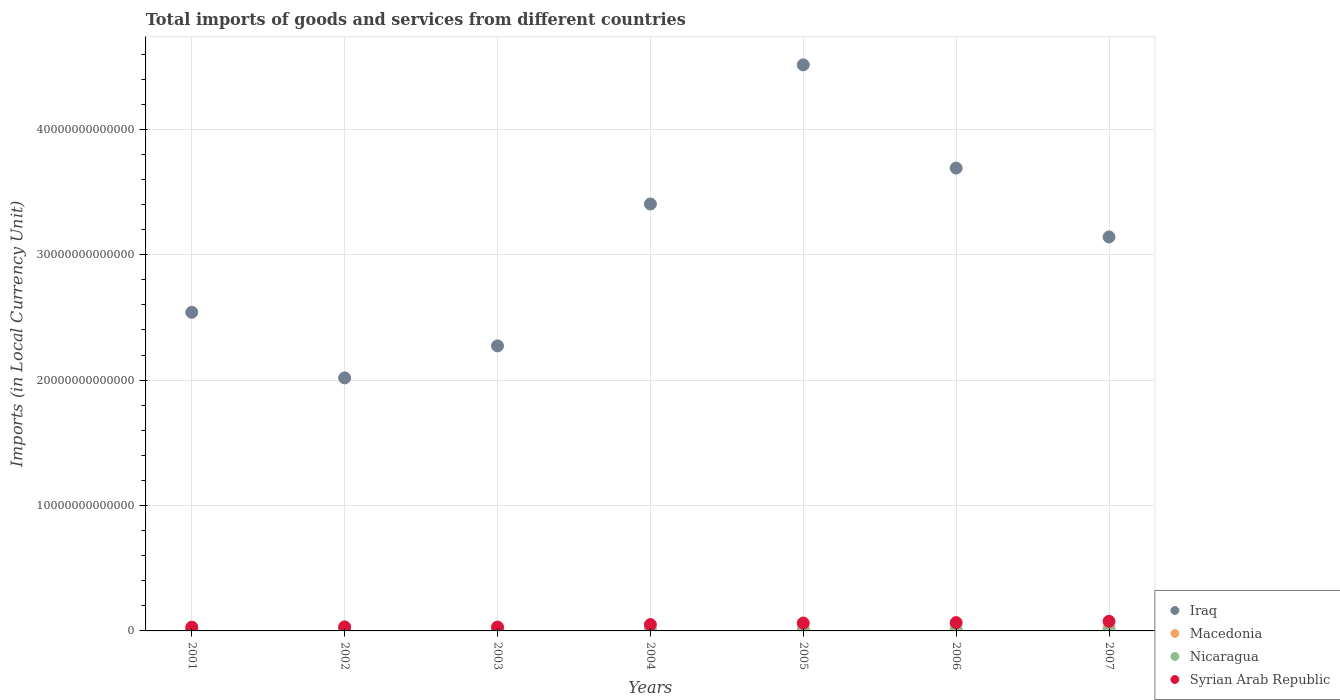What is the Amount of goods and services imports in Nicaragua in 2002?
Your answer should be compact. 2.92e+1. Across all years, what is the maximum Amount of goods and services imports in Iraq?
Your answer should be very brief. 4.51e+13. Across all years, what is the minimum Amount of goods and services imports in Macedonia?
Keep it short and to the point. 1.07e+11. In which year was the Amount of goods and services imports in Syrian Arab Republic maximum?
Provide a short and direct response. 2007. What is the total Amount of goods and services imports in Iraq in the graph?
Give a very brief answer. 2.16e+14. What is the difference between the Amount of goods and services imports in Iraq in 2003 and that in 2004?
Your response must be concise. -1.13e+13. What is the difference between the Amount of goods and services imports in Iraq in 2006 and the Amount of goods and services imports in Nicaragua in 2007?
Keep it short and to the point. 3.68e+13. What is the average Amount of goods and services imports in Nicaragua per year?
Offer a terse response. 4.49e+1. In the year 2005, what is the difference between the Amount of goods and services imports in Syrian Arab Republic and Amount of goods and services imports in Nicaragua?
Offer a terse response. 5.77e+11. What is the ratio of the Amount of goods and services imports in Nicaragua in 2001 to that in 2007?
Offer a terse response. 0.38. Is the difference between the Amount of goods and services imports in Syrian Arab Republic in 2001 and 2007 greater than the difference between the Amount of goods and services imports in Nicaragua in 2001 and 2007?
Provide a succinct answer. No. What is the difference between the highest and the second highest Amount of goods and services imports in Syrian Arab Republic?
Keep it short and to the point. 1.03e+11. What is the difference between the highest and the lowest Amount of goods and services imports in Syrian Arab Republic?
Give a very brief answer. 4.67e+11. In how many years, is the Amount of goods and services imports in Macedonia greater than the average Amount of goods and services imports in Macedonia taken over all years?
Offer a terse response. 3. Is the sum of the Amount of goods and services imports in Syrian Arab Republic in 2003 and 2005 greater than the maximum Amount of goods and services imports in Nicaragua across all years?
Give a very brief answer. Yes. Is it the case that in every year, the sum of the Amount of goods and services imports in Macedonia and Amount of goods and services imports in Nicaragua  is greater than the sum of Amount of goods and services imports in Iraq and Amount of goods and services imports in Syrian Arab Republic?
Your answer should be very brief. Yes. Is it the case that in every year, the sum of the Amount of goods and services imports in Macedonia and Amount of goods and services imports in Syrian Arab Republic  is greater than the Amount of goods and services imports in Iraq?
Make the answer very short. No. How many dotlines are there?
Offer a terse response. 4. What is the difference between two consecutive major ticks on the Y-axis?
Your response must be concise. 1.00e+13. Are the values on the major ticks of Y-axis written in scientific E-notation?
Give a very brief answer. No. Does the graph contain any zero values?
Ensure brevity in your answer.  No. Does the graph contain grids?
Your answer should be compact. Yes. Where does the legend appear in the graph?
Provide a succinct answer. Bottom right. What is the title of the graph?
Provide a succinct answer. Total imports of goods and services from different countries. What is the label or title of the X-axis?
Offer a terse response. Years. What is the label or title of the Y-axis?
Offer a terse response. Imports (in Local Currency Unit). What is the Imports (in Local Currency Unit) of Iraq in 2001?
Your answer should be compact. 2.54e+13. What is the Imports (in Local Currency Unit) in Macedonia in 2001?
Offer a very short reply. 1.07e+11. What is the Imports (in Local Currency Unit) in Nicaragua in 2001?
Ensure brevity in your answer.  2.79e+1. What is the Imports (in Local Currency Unit) of Syrian Arab Republic in 2001?
Make the answer very short. 2.97e+11. What is the Imports (in Local Currency Unit) of Iraq in 2002?
Give a very brief answer. 2.02e+13. What is the Imports (in Local Currency Unit) in Macedonia in 2002?
Offer a very short reply. 1.17e+11. What is the Imports (in Local Currency Unit) in Nicaragua in 2002?
Provide a short and direct response. 2.92e+1. What is the Imports (in Local Currency Unit) of Syrian Arab Republic in 2002?
Keep it short and to the point. 3.24e+11. What is the Imports (in Local Currency Unit) of Iraq in 2003?
Offer a very short reply. 2.27e+13. What is the Imports (in Local Currency Unit) in Macedonia in 2003?
Your answer should be very brief. 1.17e+11. What is the Imports (in Local Currency Unit) in Nicaragua in 2003?
Your answer should be very brief. 3.33e+1. What is the Imports (in Local Currency Unit) in Syrian Arab Republic in 2003?
Ensure brevity in your answer.  3.07e+11. What is the Imports (in Local Currency Unit) in Iraq in 2004?
Offer a terse response. 3.41e+13. What is the Imports (in Local Currency Unit) of Macedonia in 2004?
Your response must be concise. 1.41e+11. What is the Imports (in Local Currency Unit) of Nicaragua in 2004?
Your answer should be compact. 4.07e+1. What is the Imports (in Local Currency Unit) of Syrian Arab Republic in 2004?
Your answer should be compact. 5.04e+11. What is the Imports (in Local Currency Unit) in Iraq in 2005?
Your answer should be very brief. 4.51e+13. What is the Imports (in Local Currency Unit) in Macedonia in 2005?
Your answer should be compact. 1.57e+11. What is the Imports (in Local Currency Unit) of Nicaragua in 2005?
Give a very brief answer. 5.00e+1. What is the Imports (in Local Currency Unit) of Syrian Arab Republic in 2005?
Ensure brevity in your answer.  6.27e+11. What is the Imports (in Local Currency Unit) of Iraq in 2006?
Keep it short and to the point. 3.69e+13. What is the Imports (in Local Currency Unit) of Macedonia in 2006?
Make the answer very short. 1.83e+11. What is the Imports (in Local Currency Unit) of Nicaragua in 2006?
Provide a short and direct response. 5.93e+1. What is the Imports (in Local Currency Unit) in Syrian Arab Republic in 2006?
Your response must be concise. 6.60e+11. What is the Imports (in Local Currency Unit) of Iraq in 2007?
Offer a terse response. 3.14e+13. What is the Imports (in Local Currency Unit) in Macedonia in 2007?
Keep it short and to the point. 2.31e+11. What is the Imports (in Local Currency Unit) of Nicaragua in 2007?
Your answer should be compact. 7.37e+1. What is the Imports (in Local Currency Unit) of Syrian Arab Republic in 2007?
Provide a succinct answer. 7.63e+11. Across all years, what is the maximum Imports (in Local Currency Unit) of Iraq?
Give a very brief answer. 4.51e+13. Across all years, what is the maximum Imports (in Local Currency Unit) in Macedonia?
Make the answer very short. 2.31e+11. Across all years, what is the maximum Imports (in Local Currency Unit) of Nicaragua?
Your response must be concise. 7.37e+1. Across all years, what is the maximum Imports (in Local Currency Unit) of Syrian Arab Republic?
Your response must be concise. 7.63e+11. Across all years, what is the minimum Imports (in Local Currency Unit) in Iraq?
Give a very brief answer. 2.02e+13. Across all years, what is the minimum Imports (in Local Currency Unit) of Macedonia?
Offer a very short reply. 1.07e+11. Across all years, what is the minimum Imports (in Local Currency Unit) in Nicaragua?
Keep it short and to the point. 2.79e+1. Across all years, what is the minimum Imports (in Local Currency Unit) in Syrian Arab Republic?
Keep it short and to the point. 2.97e+11. What is the total Imports (in Local Currency Unit) in Iraq in the graph?
Give a very brief answer. 2.16e+14. What is the total Imports (in Local Currency Unit) of Macedonia in the graph?
Offer a very short reply. 1.05e+12. What is the total Imports (in Local Currency Unit) in Nicaragua in the graph?
Your answer should be very brief. 3.14e+11. What is the total Imports (in Local Currency Unit) in Syrian Arab Republic in the graph?
Ensure brevity in your answer.  3.48e+12. What is the difference between the Imports (in Local Currency Unit) in Iraq in 2001 and that in 2002?
Offer a very short reply. 5.23e+12. What is the difference between the Imports (in Local Currency Unit) in Macedonia in 2001 and that in 2002?
Provide a succinct answer. -1.03e+1. What is the difference between the Imports (in Local Currency Unit) of Nicaragua in 2001 and that in 2002?
Make the answer very short. -1.35e+09. What is the difference between the Imports (in Local Currency Unit) of Syrian Arab Republic in 2001 and that in 2002?
Your answer should be compact. -2.73e+1. What is the difference between the Imports (in Local Currency Unit) of Iraq in 2001 and that in 2003?
Your response must be concise. 2.68e+12. What is the difference between the Imports (in Local Currency Unit) of Macedonia in 2001 and that in 2003?
Make the answer very short. -9.94e+09. What is the difference between the Imports (in Local Currency Unit) in Nicaragua in 2001 and that in 2003?
Your answer should be very brief. -5.47e+09. What is the difference between the Imports (in Local Currency Unit) of Syrian Arab Republic in 2001 and that in 2003?
Give a very brief answer. -9.98e+09. What is the difference between the Imports (in Local Currency Unit) in Iraq in 2001 and that in 2004?
Your answer should be very brief. -8.64e+12. What is the difference between the Imports (in Local Currency Unit) in Macedonia in 2001 and that in 2004?
Make the answer very short. -3.41e+1. What is the difference between the Imports (in Local Currency Unit) of Nicaragua in 2001 and that in 2004?
Provide a short and direct response. -1.29e+1. What is the difference between the Imports (in Local Currency Unit) in Syrian Arab Republic in 2001 and that in 2004?
Your response must be concise. -2.07e+11. What is the difference between the Imports (in Local Currency Unit) in Iraq in 2001 and that in 2005?
Your answer should be compact. -1.97e+13. What is the difference between the Imports (in Local Currency Unit) of Macedonia in 2001 and that in 2005?
Keep it short and to the point. -5.07e+1. What is the difference between the Imports (in Local Currency Unit) of Nicaragua in 2001 and that in 2005?
Your answer should be compact. -2.21e+1. What is the difference between the Imports (in Local Currency Unit) in Syrian Arab Republic in 2001 and that in 2005?
Offer a very short reply. -3.30e+11. What is the difference between the Imports (in Local Currency Unit) of Iraq in 2001 and that in 2006?
Your answer should be very brief. -1.15e+13. What is the difference between the Imports (in Local Currency Unit) of Macedonia in 2001 and that in 2006?
Provide a short and direct response. -7.66e+1. What is the difference between the Imports (in Local Currency Unit) in Nicaragua in 2001 and that in 2006?
Your answer should be compact. -3.14e+1. What is the difference between the Imports (in Local Currency Unit) of Syrian Arab Republic in 2001 and that in 2006?
Provide a short and direct response. -3.63e+11. What is the difference between the Imports (in Local Currency Unit) of Iraq in 2001 and that in 2007?
Make the answer very short. -6.01e+12. What is the difference between the Imports (in Local Currency Unit) of Macedonia in 2001 and that in 2007?
Your answer should be compact. -1.24e+11. What is the difference between the Imports (in Local Currency Unit) in Nicaragua in 2001 and that in 2007?
Provide a succinct answer. -4.58e+1. What is the difference between the Imports (in Local Currency Unit) in Syrian Arab Republic in 2001 and that in 2007?
Ensure brevity in your answer.  -4.67e+11. What is the difference between the Imports (in Local Currency Unit) of Iraq in 2002 and that in 2003?
Your answer should be compact. -2.55e+12. What is the difference between the Imports (in Local Currency Unit) of Macedonia in 2002 and that in 2003?
Offer a terse response. 3.15e+08. What is the difference between the Imports (in Local Currency Unit) of Nicaragua in 2002 and that in 2003?
Provide a succinct answer. -4.12e+09. What is the difference between the Imports (in Local Currency Unit) of Syrian Arab Republic in 2002 and that in 2003?
Provide a succinct answer. 1.73e+1. What is the difference between the Imports (in Local Currency Unit) of Iraq in 2002 and that in 2004?
Your answer should be very brief. -1.39e+13. What is the difference between the Imports (in Local Currency Unit) in Macedonia in 2002 and that in 2004?
Your answer should be compact. -2.39e+1. What is the difference between the Imports (in Local Currency Unit) of Nicaragua in 2002 and that in 2004?
Keep it short and to the point. -1.15e+1. What is the difference between the Imports (in Local Currency Unit) in Syrian Arab Republic in 2002 and that in 2004?
Ensure brevity in your answer.  -1.80e+11. What is the difference between the Imports (in Local Currency Unit) of Iraq in 2002 and that in 2005?
Your answer should be very brief. -2.50e+13. What is the difference between the Imports (in Local Currency Unit) in Macedonia in 2002 and that in 2005?
Ensure brevity in your answer.  -4.04e+1. What is the difference between the Imports (in Local Currency Unit) of Nicaragua in 2002 and that in 2005?
Make the answer very short. -2.08e+1. What is the difference between the Imports (in Local Currency Unit) of Syrian Arab Republic in 2002 and that in 2005?
Provide a succinct answer. -3.03e+11. What is the difference between the Imports (in Local Currency Unit) of Iraq in 2002 and that in 2006?
Keep it short and to the point. -1.67e+13. What is the difference between the Imports (in Local Currency Unit) of Macedonia in 2002 and that in 2006?
Keep it short and to the point. -6.64e+1. What is the difference between the Imports (in Local Currency Unit) in Nicaragua in 2002 and that in 2006?
Ensure brevity in your answer.  -3.01e+1. What is the difference between the Imports (in Local Currency Unit) of Syrian Arab Republic in 2002 and that in 2006?
Ensure brevity in your answer.  -3.36e+11. What is the difference between the Imports (in Local Currency Unit) of Iraq in 2002 and that in 2007?
Make the answer very short. -1.12e+13. What is the difference between the Imports (in Local Currency Unit) in Macedonia in 2002 and that in 2007?
Your answer should be very brief. -1.14e+11. What is the difference between the Imports (in Local Currency Unit) in Nicaragua in 2002 and that in 2007?
Give a very brief answer. -4.44e+1. What is the difference between the Imports (in Local Currency Unit) in Syrian Arab Republic in 2002 and that in 2007?
Your response must be concise. -4.39e+11. What is the difference between the Imports (in Local Currency Unit) of Iraq in 2003 and that in 2004?
Ensure brevity in your answer.  -1.13e+13. What is the difference between the Imports (in Local Currency Unit) of Macedonia in 2003 and that in 2004?
Keep it short and to the point. -2.42e+1. What is the difference between the Imports (in Local Currency Unit) of Nicaragua in 2003 and that in 2004?
Your response must be concise. -7.41e+09. What is the difference between the Imports (in Local Currency Unit) of Syrian Arab Republic in 2003 and that in 2004?
Provide a succinct answer. -1.98e+11. What is the difference between the Imports (in Local Currency Unit) of Iraq in 2003 and that in 2005?
Make the answer very short. -2.24e+13. What is the difference between the Imports (in Local Currency Unit) of Macedonia in 2003 and that in 2005?
Your answer should be compact. -4.08e+1. What is the difference between the Imports (in Local Currency Unit) in Nicaragua in 2003 and that in 2005?
Your answer should be very brief. -1.67e+1. What is the difference between the Imports (in Local Currency Unit) of Syrian Arab Republic in 2003 and that in 2005?
Provide a succinct answer. -3.20e+11. What is the difference between the Imports (in Local Currency Unit) in Iraq in 2003 and that in 2006?
Your answer should be compact. -1.42e+13. What is the difference between the Imports (in Local Currency Unit) of Macedonia in 2003 and that in 2006?
Ensure brevity in your answer.  -6.67e+1. What is the difference between the Imports (in Local Currency Unit) of Nicaragua in 2003 and that in 2006?
Provide a short and direct response. -2.59e+1. What is the difference between the Imports (in Local Currency Unit) of Syrian Arab Republic in 2003 and that in 2006?
Provide a short and direct response. -3.53e+11. What is the difference between the Imports (in Local Currency Unit) of Iraq in 2003 and that in 2007?
Give a very brief answer. -8.69e+12. What is the difference between the Imports (in Local Currency Unit) in Macedonia in 2003 and that in 2007?
Provide a succinct answer. -1.14e+11. What is the difference between the Imports (in Local Currency Unit) of Nicaragua in 2003 and that in 2007?
Provide a succinct answer. -4.03e+1. What is the difference between the Imports (in Local Currency Unit) of Syrian Arab Republic in 2003 and that in 2007?
Make the answer very short. -4.57e+11. What is the difference between the Imports (in Local Currency Unit) in Iraq in 2004 and that in 2005?
Your response must be concise. -1.11e+13. What is the difference between the Imports (in Local Currency Unit) of Macedonia in 2004 and that in 2005?
Make the answer very short. -1.66e+1. What is the difference between the Imports (in Local Currency Unit) in Nicaragua in 2004 and that in 2005?
Provide a short and direct response. -9.25e+09. What is the difference between the Imports (in Local Currency Unit) of Syrian Arab Republic in 2004 and that in 2005?
Offer a terse response. -1.23e+11. What is the difference between the Imports (in Local Currency Unit) in Iraq in 2004 and that in 2006?
Provide a succinct answer. -2.86e+12. What is the difference between the Imports (in Local Currency Unit) in Macedonia in 2004 and that in 2006?
Make the answer very short. -4.25e+1. What is the difference between the Imports (in Local Currency Unit) of Nicaragua in 2004 and that in 2006?
Your response must be concise. -1.85e+1. What is the difference between the Imports (in Local Currency Unit) in Syrian Arab Republic in 2004 and that in 2006?
Offer a very short reply. -1.56e+11. What is the difference between the Imports (in Local Currency Unit) of Iraq in 2004 and that in 2007?
Your answer should be compact. 2.63e+12. What is the difference between the Imports (in Local Currency Unit) in Macedonia in 2004 and that in 2007?
Provide a short and direct response. -9.02e+1. What is the difference between the Imports (in Local Currency Unit) in Nicaragua in 2004 and that in 2007?
Keep it short and to the point. -3.29e+1. What is the difference between the Imports (in Local Currency Unit) of Syrian Arab Republic in 2004 and that in 2007?
Your response must be concise. -2.59e+11. What is the difference between the Imports (in Local Currency Unit) of Iraq in 2005 and that in 2006?
Ensure brevity in your answer.  8.23e+12. What is the difference between the Imports (in Local Currency Unit) of Macedonia in 2005 and that in 2006?
Provide a succinct answer. -2.59e+1. What is the difference between the Imports (in Local Currency Unit) in Nicaragua in 2005 and that in 2006?
Offer a very short reply. -9.29e+09. What is the difference between the Imports (in Local Currency Unit) of Syrian Arab Republic in 2005 and that in 2006?
Your answer should be compact. -3.32e+1. What is the difference between the Imports (in Local Currency Unit) of Iraq in 2005 and that in 2007?
Your response must be concise. 1.37e+13. What is the difference between the Imports (in Local Currency Unit) in Macedonia in 2005 and that in 2007?
Your answer should be very brief. -7.37e+1. What is the difference between the Imports (in Local Currency Unit) of Nicaragua in 2005 and that in 2007?
Ensure brevity in your answer.  -2.37e+1. What is the difference between the Imports (in Local Currency Unit) in Syrian Arab Republic in 2005 and that in 2007?
Your answer should be compact. -1.36e+11. What is the difference between the Imports (in Local Currency Unit) in Iraq in 2006 and that in 2007?
Make the answer very short. 5.49e+12. What is the difference between the Imports (in Local Currency Unit) of Macedonia in 2006 and that in 2007?
Your response must be concise. -4.77e+1. What is the difference between the Imports (in Local Currency Unit) in Nicaragua in 2006 and that in 2007?
Offer a very short reply. -1.44e+1. What is the difference between the Imports (in Local Currency Unit) of Syrian Arab Republic in 2006 and that in 2007?
Offer a very short reply. -1.03e+11. What is the difference between the Imports (in Local Currency Unit) of Iraq in 2001 and the Imports (in Local Currency Unit) of Macedonia in 2002?
Provide a short and direct response. 2.53e+13. What is the difference between the Imports (in Local Currency Unit) in Iraq in 2001 and the Imports (in Local Currency Unit) in Nicaragua in 2002?
Your answer should be compact. 2.54e+13. What is the difference between the Imports (in Local Currency Unit) of Iraq in 2001 and the Imports (in Local Currency Unit) of Syrian Arab Republic in 2002?
Keep it short and to the point. 2.51e+13. What is the difference between the Imports (in Local Currency Unit) of Macedonia in 2001 and the Imports (in Local Currency Unit) of Nicaragua in 2002?
Keep it short and to the point. 7.75e+1. What is the difference between the Imports (in Local Currency Unit) in Macedonia in 2001 and the Imports (in Local Currency Unit) in Syrian Arab Republic in 2002?
Offer a very short reply. -2.17e+11. What is the difference between the Imports (in Local Currency Unit) of Nicaragua in 2001 and the Imports (in Local Currency Unit) of Syrian Arab Republic in 2002?
Keep it short and to the point. -2.96e+11. What is the difference between the Imports (in Local Currency Unit) in Iraq in 2001 and the Imports (in Local Currency Unit) in Macedonia in 2003?
Offer a terse response. 2.53e+13. What is the difference between the Imports (in Local Currency Unit) in Iraq in 2001 and the Imports (in Local Currency Unit) in Nicaragua in 2003?
Your answer should be very brief. 2.54e+13. What is the difference between the Imports (in Local Currency Unit) of Iraq in 2001 and the Imports (in Local Currency Unit) of Syrian Arab Republic in 2003?
Your answer should be compact. 2.51e+13. What is the difference between the Imports (in Local Currency Unit) of Macedonia in 2001 and the Imports (in Local Currency Unit) of Nicaragua in 2003?
Your answer should be compact. 7.34e+1. What is the difference between the Imports (in Local Currency Unit) in Macedonia in 2001 and the Imports (in Local Currency Unit) in Syrian Arab Republic in 2003?
Offer a terse response. -2.00e+11. What is the difference between the Imports (in Local Currency Unit) in Nicaragua in 2001 and the Imports (in Local Currency Unit) in Syrian Arab Republic in 2003?
Your answer should be very brief. -2.79e+11. What is the difference between the Imports (in Local Currency Unit) of Iraq in 2001 and the Imports (in Local Currency Unit) of Macedonia in 2004?
Give a very brief answer. 2.53e+13. What is the difference between the Imports (in Local Currency Unit) of Iraq in 2001 and the Imports (in Local Currency Unit) of Nicaragua in 2004?
Provide a short and direct response. 2.54e+13. What is the difference between the Imports (in Local Currency Unit) in Iraq in 2001 and the Imports (in Local Currency Unit) in Syrian Arab Republic in 2004?
Keep it short and to the point. 2.49e+13. What is the difference between the Imports (in Local Currency Unit) in Macedonia in 2001 and the Imports (in Local Currency Unit) in Nicaragua in 2004?
Ensure brevity in your answer.  6.60e+1. What is the difference between the Imports (in Local Currency Unit) of Macedonia in 2001 and the Imports (in Local Currency Unit) of Syrian Arab Republic in 2004?
Ensure brevity in your answer.  -3.98e+11. What is the difference between the Imports (in Local Currency Unit) in Nicaragua in 2001 and the Imports (in Local Currency Unit) in Syrian Arab Republic in 2004?
Your response must be concise. -4.77e+11. What is the difference between the Imports (in Local Currency Unit) of Iraq in 2001 and the Imports (in Local Currency Unit) of Macedonia in 2005?
Your response must be concise. 2.53e+13. What is the difference between the Imports (in Local Currency Unit) in Iraq in 2001 and the Imports (in Local Currency Unit) in Nicaragua in 2005?
Provide a short and direct response. 2.54e+13. What is the difference between the Imports (in Local Currency Unit) in Iraq in 2001 and the Imports (in Local Currency Unit) in Syrian Arab Republic in 2005?
Give a very brief answer. 2.48e+13. What is the difference between the Imports (in Local Currency Unit) in Macedonia in 2001 and the Imports (in Local Currency Unit) in Nicaragua in 2005?
Your response must be concise. 5.67e+1. What is the difference between the Imports (in Local Currency Unit) in Macedonia in 2001 and the Imports (in Local Currency Unit) in Syrian Arab Republic in 2005?
Your answer should be very brief. -5.20e+11. What is the difference between the Imports (in Local Currency Unit) of Nicaragua in 2001 and the Imports (in Local Currency Unit) of Syrian Arab Republic in 2005?
Offer a very short reply. -5.99e+11. What is the difference between the Imports (in Local Currency Unit) of Iraq in 2001 and the Imports (in Local Currency Unit) of Macedonia in 2006?
Provide a short and direct response. 2.52e+13. What is the difference between the Imports (in Local Currency Unit) of Iraq in 2001 and the Imports (in Local Currency Unit) of Nicaragua in 2006?
Give a very brief answer. 2.54e+13. What is the difference between the Imports (in Local Currency Unit) in Iraq in 2001 and the Imports (in Local Currency Unit) in Syrian Arab Republic in 2006?
Your answer should be compact. 2.48e+13. What is the difference between the Imports (in Local Currency Unit) of Macedonia in 2001 and the Imports (in Local Currency Unit) of Nicaragua in 2006?
Your response must be concise. 4.74e+1. What is the difference between the Imports (in Local Currency Unit) of Macedonia in 2001 and the Imports (in Local Currency Unit) of Syrian Arab Republic in 2006?
Ensure brevity in your answer.  -5.54e+11. What is the difference between the Imports (in Local Currency Unit) of Nicaragua in 2001 and the Imports (in Local Currency Unit) of Syrian Arab Republic in 2006?
Keep it short and to the point. -6.32e+11. What is the difference between the Imports (in Local Currency Unit) in Iraq in 2001 and the Imports (in Local Currency Unit) in Macedonia in 2007?
Your response must be concise. 2.52e+13. What is the difference between the Imports (in Local Currency Unit) of Iraq in 2001 and the Imports (in Local Currency Unit) of Nicaragua in 2007?
Offer a terse response. 2.53e+13. What is the difference between the Imports (in Local Currency Unit) of Iraq in 2001 and the Imports (in Local Currency Unit) of Syrian Arab Republic in 2007?
Your answer should be compact. 2.46e+13. What is the difference between the Imports (in Local Currency Unit) in Macedonia in 2001 and the Imports (in Local Currency Unit) in Nicaragua in 2007?
Make the answer very short. 3.31e+1. What is the difference between the Imports (in Local Currency Unit) of Macedonia in 2001 and the Imports (in Local Currency Unit) of Syrian Arab Republic in 2007?
Offer a terse response. -6.57e+11. What is the difference between the Imports (in Local Currency Unit) of Nicaragua in 2001 and the Imports (in Local Currency Unit) of Syrian Arab Republic in 2007?
Provide a succinct answer. -7.36e+11. What is the difference between the Imports (in Local Currency Unit) of Iraq in 2002 and the Imports (in Local Currency Unit) of Macedonia in 2003?
Ensure brevity in your answer.  2.01e+13. What is the difference between the Imports (in Local Currency Unit) of Iraq in 2002 and the Imports (in Local Currency Unit) of Nicaragua in 2003?
Your response must be concise. 2.01e+13. What is the difference between the Imports (in Local Currency Unit) in Iraq in 2002 and the Imports (in Local Currency Unit) in Syrian Arab Republic in 2003?
Keep it short and to the point. 1.99e+13. What is the difference between the Imports (in Local Currency Unit) of Macedonia in 2002 and the Imports (in Local Currency Unit) of Nicaragua in 2003?
Provide a short and direct response. 8.36e+1. What is the difference between the Imports (in Local Currency Unit) in Macedonia in 2002 and the Imports (in Local Currency Unit) in Syrian Arab Republic in 2003?
Offer a terse response. -1.90e+11. What is the difference between the Imports (in Local Currency Unit) in Nicaragua in 2002 and the Imports (in Local Currency Unit) in Syrian Arab Republic in 2003?
Your response must be concise. -2.78e+11. What is the difference between the Imports (in Local Currency Unit) in Iraq in 2002 and the Imports (in Local Currency Unit) in Macedonia in 2004?
Make the answer very short. 2.00e+13. What is the difference between the Imports (in Local Currency Unit) of Iraq in 2002 and the Imports (in Local Currency Unit) of Nicaragua in 2004?
Give a very brief answer. 2.01e+13. What is the difference between the Imports (in Local Currency Unit) in Iraq in 2002 and the Imports (in Local Currency Unit) in Syrian Arab Republic in 2004?
Offer a very short reply. 1.97e+13. What is the difference between the Imports (in Local Currency Unit) in Macedonia in 2002 and the Imports (in Local Currency Unit) in Nicaragua in 2004?
Your answer should be very brief. 7.62e+1. What is the difference between the Imports (in Local Currency Unit) of Macedonia in 2002 and the Imports (in Local Currency Unit) of Syrian Arab Republic in 2004?
Keep it short and to the point. -3.87e+11. What is the difference between the Imports (in Local Currency Unit) in Nicaragua in 2002 and the Imports (in Local Currency Unit) in Syrian Arab Republic in 2004?
Ensure brevity in your answer.  -4.75e+11. What is the difference between the Imports (in Local Currency Unit) of Iraq in 2002 and the Imports (in Local Currency Unit) of Macedonia in 2005?
Your answer should be very brief. 2.00e+13. What is the difference between the Imports (in Local Currency Unit) in Iraq in 2002 and the Imports (in Local Currency Unit) in Nicaragua in 2005?
Give a very brief answer. 2.01e+13. What is the difference between the Imports (in Local Currency Unit) of Iraq in 2002 and the Imports (in Local Currency Unit) of Syrian Arab Republic in 2005?
Provide a short and direct response. 1.96e+13. What is the difference between the Imports (in Local Currency Unit) of Macedonia in 2002 and the Imports (in Local Currency Unit) of Nicaragua in 2005?
Ensure brevity in your answer.  6.70e+1. What is the difference between the Imports (in Local Currency Unit) in Macedonia in 2002 and the Imports (in Local Currency Unit) in Syrian Arab Republic in 2005?
Provide a succinct answer. -5.10e+11. What is the difference between the Imports (in Local Currency Unit) of Nicaragua in 2002 and the Imports (in Local Currency Unit) of Syrian Arab Republic in 2005?
Your answer should be very brief. -5.98e+11. What is the difference between the Imports (in Local Currency Unit) of Iraq in 2002 and the Imports (in Local Currency Unit) of Macedonia in 2006?
Ensure brevity in your answer.  2.00e+13. What is the difference between the Imports (in Local Currency Unit) of Iraq in 2002 and the Imports (in Local Currency Unit) of Nicaragua in 2006?
Provide a short and direct response. 2.01e+13. What is the difference between the Imports (in Local Currency Unit) of Iraq in 2002 and the Imports (in Local Currency Unit) of Syrian Arab Republic in 2006?
Offer a very short reply. 1.95e+13. What is the difference between the Imports (in Local Currency Unit) in Macedonia in 2002 and the Imports (in Local Currency Unit) in Nicaragua in 2006?
Offer a very short reply. 5.77e+1. What is the difference between the Imports (in Local Currency Unit) in Macedonia in 2002 and the Imports (in Local Currency Unit) in Syrian Arab Republic in 2006?
Offer a very short reply. -5.43e+11. What is the difference between the Imports (in Local Currency Unit) in Nicaragua in 2002 and the Imports (in Local Currency Unit) in Syrian Arab Republic in 2006?
Offer a very short reply. -6.31e+11. What is the difference between the Imports (in Local Currency Unit) of Iraq in 2002 and the Imports (in Local Currency Unit) of Macedonia in 2007?
Give a very brief answer. 1.99e+13. What is the difference between the Imports (in Local Currency Unit) of Iraq in 2002 and the Imports (in Local Currency Unit) of Nicaragua in 2007?
Provide a short and direct response. 2.01e+13. What is the difference between the Imports (in Local Currency Unit) of Iraq in 2002 and the Imports (in Local Currency Unit) of Syrian Arab Republic in 2007?
Your response must be concise. 1.94e+13. What is the difference between the Imports (in Local Currency Unit) in Macedonia in 2002 and the Imports (in Local Currency Unit) in Nicaragua in 2007?
Give a very brief answer. 4.33e+1. What is the difference between the Imports (in Local Currency Unit) of Macedonia in 2002 and the Imports (in Local Currency Unit) of Syrian Arab Republic in 2007?
Ensure brevity in your answer.  -6.46e+11. What is the difference between the Imports (in Local Currency Unit) of Nicaragua in 2002 and the Imports (in Local Currency Unit) of Syrian Arab Republic in 2007?
Provide a short and direct response. -7.34e+11. What is the difference between the Imports (in Local Currency Unit) of Iraq in 2003 and the Imports (in Local Currency Unit) of Macedonia in 2004?
Offer a very short reply. 2.26e+13. What is the difference between the Imports (in Local Currency Unit) of Iraq in 2003 and the Imports (in Local Currency Unit) of Nicaragua in 2004?
Offer a terse response. 2.27e+13. What is the difference between the Imports (in Local Currency Unit) in Iraq in 2003 and the Imports (in Local Currency Unit) in Syrian Arab Republic in 2004?
Make the answer very short. 2.22e+13. What is the difference between the Imports (in Local Currency Unit) in Macedonia in 2003 and the Imports (in Local Currency Unit) in Nicaragua in 2004?
Your answer should be compact. 7.59e+1. What is the difference between the Imports (in Local Currency Unit) in Macedonia in 2003 and the Imports (in Local Currency Unit) in Syrian Arab Republic in 2004?
Offer a very short reply. -3.88e+11. What is the difference between the Imports (in Local Currency Unit) in Nicaragua in 2003 and the Imports (in Local Currency Unit) in Syrian Arab Republic in 2004?
Ensure brevity in your answer.  -4.71e+11. What is the difference between the Imports (in Local Currency Unit) of Iraq in 2003 and the Imports (in Local Currency Unit) of Macedonia in 2005?
Offer a very short reply. 2.26e+13. What is the difference between the Imports (in Local Currency Unit) of Iraq in 2003 and the Imports (in Local Currency Unit) of Nicaragua in 2005?
Your answer should be compact. 2.27e+13. What is the difference between the Imports (in Local Currency Unit) in Iraq in 2003 and the Imports (in Local Currency Unit) in Syrian Arab Republic in 2005?
Offer a terse response. 2.21e+13. What is the difference between the Imports (in Local Currency Unit) in Macedonia in 2003 and the Imports (in Local Currency Unit) in Nicaragua in 2005?
Provide a short and direct response. 6.67e+1. What is the difference between the Imports (in Local Currency Unit) in Macedonia in 2003 and the Imports (in Local Currency Unit) in Syrian Arab Republic in 2005?
Give a very brief answer. -5.10e+11. What is the difference between the Imports (in Local Currency Unit) of Nicaragua in 2003 and the Imports (in Local Currency Unit) of Syrian Arab Republic in 2005?
Your answer should be very brief. -5.94e+11. What is the difference between the Imports (in Local Currency Unit) in Iraq in 2003 and the Imports (in Local Currency Unit) in Macedonia in 2006?
Offer a very short reply. 2.26e+13. What is the difference between the Imports (in Local Currency Unit) of Iraq in 2003 and the Imports (in Local Currency Unit) of Nicaragua in 2006?
Keep it short and to the point. 2.27e+13. What is the difference between the Imports (in Local Currency Unit) in Iraq in 2003 and the Imports (in Local Currency Unit) in Syrian Arab Republic in 2006?
Your answer should be very brief. 2.21e+13. What is the difference between the Imports (in Local Currency Unit) of Macedonia in 2003 and the Imports (in Local Currency Unit) of Nicaragua in 2006?
Your answer should be compact. 5.74e+1. What is the difference between the Imports (in Local Currency Unit) of Macedonia in 2003 and the Imports (in Local Currency Unit) of Syrian Arab Republic in 2006?
Provide a succinct answer. -5.44e+11. What is the difference between the Imports (in Local Currency Unit) in Nicaragua in 2003 and the Imports (in Local Currency Unit) in Syrian Arab Republic in 2006?
Provide a succinct answer. -6.27e+11. What is the difference between the Imports (in Local Currency Unit) in Iraq in 2003 and the Imports (in Local Currency Unit) in Macedonia in 2007?
Your answer should be very brief. 2.25e+13. What is the difference between the Imports (in Local Currency Unit) of Iraq in 2003 and the Imports (in Local Currency Unit) of Nicaragua in 2007?
Your answer should be very brief. 2.27e+13. What is the difference between the Imports (in Local Currency Unit) in Iraq in 2003 and the Imports (in Local Currency Unit) in Syrian Arab Republic in 2007?
Provide a succinct answer. 2.20e+13. What is the difference between the Imports (in Local Currency Unit) in Macedonia in 2003 and the Imports (in Local Currency Unit) in Nicaragua in 2007?
Your answer should be compact. 4.30e+1. What is the difference between the Imports (in Local Currency Unit) of Macedonia in 2003 and the Imports (in Local Currency Unit) of Syrian Arab Republic in 2007?
Offer a very short reply. -6.47e+11. What is the difference between the Imports (in Local Currency Unit) in Nicaragua in 2003 and the Imports (in Local Currency Unit) in Syrian Arab Republic in 2007?
Keep it short and to the point. -7.30e+11. What is the difference between the Imports (in Local Currency Unit) in Iraq in 2004 and the Imports (in Local Currency Unit) in Macedonia in 2005?
Keep it short and to the point. 3.39e+13. What is the difference between the Imports (in Local Currency Unit) of Iraq in 2004 and the Imports (in Local Currency Unit) of Nicaragua in 2005?
Give a very brief answer. 3.40e+13. What is the difference between the Imports (in Local Currency Unit) of Iraq in 2004 and the Imports (in Local Currency Unit) of Syrian Arab Republic in 2005?
Provide a succinct answer. 3.34e+13. What is the difference between the Imports (in Local Currency Unit) of Macedonia in 2004 and the Imports (in Local Currency Unit) of Nicaragua in 2005?
Ensure brevity in your answer.  9.09e+1. What is the difference between the Imports (in Local Currency Unit) of Macedonia in 2004 and the Imports (in Local Currency Unit) of Syrian Arab Republic in 2005?
Your answer should be very brief. -4.86e+11. What is the difference between the Imports (in Local Currency Unit) of Nicaragua in 2004 and the Imports (in Local Currency Unit) of Syrian Arab Republic in 2005?
Offer a very short reply. -5.86e+11. What is the difference between the Imports (in Local Currency Unit) of Iraq in 2004 and the Imports (in Local Currency Unit) of Macedonia in 2006?
Offer a terse response. 3.39e+13. What is the difference between the Imports (in Local Currency Unit) in Iraq in 2004 and the Imports (in Local Currency Unit) in Nicaragua in 2006?
Ensure brevity in your answer.  3.40e+13. What is the difference between the Imports (in Local Currency Unit) of Iraq in 2004 and the Imports (in Local Currency Unit) of Syrian Arab Republic in 2006?
Give a very brief answer. 3.34e+13. What is the difference between the Imports (in Local Currency Unit) in Macedonia in 2004 and the Imports (in Local Currency Unit) in Nicaragua in 2006?
Your answer should be compact. 8.16e+1. What is the difference between the Imports (in Local Currency Unit) of Macedonia in 2004 and the Imports (in Local Currency Unit) of Syrian Arab Republic in 2006?
Provide a succinct answer. -5.19e+11. What is the difference between the Imports (in Local Currency Unit) in Nicaragua in 2004 and the Imports (in Local Currency Unit) in Syrian Arab Republic in 2006?
Provide a succinct answer. -6.19e+11. What is the difference between the Imports (in Local Currency Unit) in Iraq in 2004 and the Imports (in Local Currency Unit) in Macedonia in 2007?
Make the answer very short. 3.38e+13. What is the difference between the Imports (in Local Currency Unit) in Iraq in 2004 and the Imports (in Local Currency Unit) in Nicaragua in 2007?
Your response must be concise. 3.40e+13. What is the difference between the Imports (in Local Currency Unit) in Iraq in 2004 and the Imports (in Local Currency Unit) in Syrian Arab Republic in 2007?
Your answer should be very brief. 3.33e+13. What is the difference between the Imports (in Local Currency Unit) of Macedonia in 2004 and the Imports (in Local Currency Unit) of Nicaragua in 2007?
Offer a terse response. 6.72e+1. What is the difference between the Imports (in Local Currency Unit) in Macedonia in 2004 and the Imports (in Local Currency Unit) in Syrian Arab Republic in 2007?
Your answer should be compact. -6.23e+11. What is the difference between the Imports (in Local Currency Unit) of Nicaragua in 2004 and the Imports (in Local Currency Unit) of Syrian Arab Republic in 2007?
Keep it short and to the point. -7.23e+11. What is the difference between the Imports (in Local Currency Unit) in Iraq in 2005 and the Imports (in Local Currency Unit) in Macedonia in 2006?
Make the answer very short. 4.50e+13. What is the difference between the Imports (in Local Currency Unit) in Iraq in 2005 and the Imports (in Local Currency Unit) in Nicaragua in 2006?
Offer a very short reply. 4.51e+13. What is the difference between the Imports (in Local Currency Unit) of Iraq in 2005 and the Imports (in Local Currency Unit) of Syrian Arab Republic in 2006?
Make the answer very short. 4.45e+13. What is the difference between the Imports (in Local Currency Unit) of Macedonia in 2005 and the Imports (in Local Currency Unit) of Nicaragua in 2006?
Offer a very short reply. 9.81e+1. What is the difference between the Imports (in Local Currency Unit) of Macedonia in 2005 and the Imports (in Local Currency Unit) of Syrian Arab Republic in 2006?
Offer a very short reply. -5.03e+11. What is the difference between the Imports (in Local Currency Unit) in Nicaragua in 2005 and the Imports (in Local Currency Unit) in Syrian Arab Republic in 2006?
Provide a succinct answer. -6.10e+11. What is the difference between the Imports (in Local Currency Unit) in Iraq in 2005 and the Imports (in Local Currency Unit) in Macedonia in 2007?
Your answer should be compact. 4.49e+13. What is the difference between the Imports (in Local Currency Unit) in Iraq in 2005 and the Imports (in Local Currency Unit) in Nicaragua in 2007?
Provide a succinct answer. 4.51e+13. What is the difference between the Imports (in Local Currency Unit) of Iraq in 2005 and the Imports (in Local Currency Unit) of Syrian Arab Republic in 2007?
Your answer should be very brief. 4.44e+13. What is the difference between the Imports (in Local Currency Unit) of Macedonia in 2005 and the Imports (in Local Currency Unit) of Nicaragua in 2007?
Offer a terse response. 8.38e+1. What is the difference between the Imports (in Local Currency Unit) in Macedonia in 2005 and the Imports (in Local Currency Unit) in Syrian Arab Republic in 2007?
Offer a very short reply. -6.06e+11. What is the difference between the Imports (in Local Currency Unit) in Nicaragua in 2005 and the Imports (in Local Currency Unit) in Syrian Arab Republic in 2007?
Provide a short and direct response. -7.13e+11. What is the difference between the Imports (in Local Currency Unit) in Iraq in 2006 and the Imports (in Local Currency Unit) in Macedonia in 2007?
Your answer should be compact. 3.67e+13. What is the difference between the Imports (in Local Currency Unit) of Iraq in 2006 and the Imports (in Local Currency Unit) of Nicaragua in 2007?
Give a very brief answer. 3.68e+13. What is the difference between the Imports (in Local Currency Unit) of Iraq in 2006 and the Imports (in Local Currency Unit) of Syrian Arab Republic in 2007?
Your answer should be compact. 3.62e+13. What is the difference between the Imports (in Local Currency Unit) of Macedonia in 2006 and the Imports (in Local Currency Unit) of Nicaragua in 2007?
Give a very brief answer. 1.10e+11. What is the difference between the Imports (in Local Currency Unit) in Macedonia in 2006 and the Imports (in Local Currency Unit) in Syrian Arab Republic in 2007?
Give a very brief answer. -5.80e+11. What is the difference between the Imports (in Local Currency Unit) in Nicaragua in 2006 and the Imports (in Local Currency Unit) in Syrian Arab Republic in 2007?
Your answer should be compact. -7.04e+11. What is the average Imports (in Local Currency Unit) of Iraq per year?
Provide a succinct answer. 3.08e+13. What is the average Imports (in Local Currency Unit) in Macedonia per year?
Your response must be concise. 1.50e+11. What is the average Imports (in Local Currency Unit) in Nicaragua per year?
Keep it short and to the point. 4.49e+1. What is the average Imports (in Local Currency Unit) in Syrian Arab Republic per year?
Your answer should be very brief. 4.98e+11. In the year 2001, what is the difference between the Imports (in Local Currency Unit) of Iraq and Imports (in Local Currency Unit) of Macedonia?
Your answer should be very brief. 2.53e+13. In the year 2001, what is the difference between the Imports (in Local Currency Unit) in Iraq and Imports (in Local Currency Unit) in Nicaragua?
Keep it short and to the point. 2.54e+13. In the year 2001, what is the difference between the Imports (in Local Currency Unit) of Iraq and Imports (in Local Currency Unit) of Syrian Arab Republic?
Your response must be concise. 2.51e+13. In the year 2001, what is the difference between the Imports (in Local Currency Unit) in Macedonia and Imports (in Local Currency Unit) in Nicaragua?
Provide a succinct answer. 7.88e+1. In the year 2001, what is the difference between the Imports (in Local Currency Unit) of Macedonia and Imports (in Local Currency Unit) of Syrian Arab Republic?
Offer a terse response. -1.90e+11. In the year 2001, what is the difference between the Imports (in Local Currency Unit) of Nicaragua and Imports (in Local Currency Unit) of Syrian Arab Republic?
Your answer should be compact. -2.69e+11. In the year 2002, what is the difference between the Imports (in Local Currency Unit) of Iraq and Imports (in Local Currency Unit) of Macedonia?
Your answer should be very brief. 2.01e+13. In the year 2002, what is the difference between the Imports (in Local Currency Unit) of Iraq and Imports (in Local Currency Unit) of Nicaragua?
Offer a terse response. 2.02e+13. In the year 2002, what is the difference between the Imports (in Local Currency Unit) in Iraq and Imports (in Local Currency Unit) in Syrian Arab Republic?
Keep it short and to the point. 1.99e+13. In the year 2002, what is the difference between the Imports (in Local Currency Unit) of Macedonia and Imports (in Local Currency Unit) of Nicaragua?
Provide a short and direct response. 8.77e+1. In the year 2002, what is the difference between the Imports (in Local Currency Unit) of Macedonia and Imports (in Local Currency Unit) of Syrian Arab Republic?
Offer a very short reply. -2.07e+11. In the year 2002, what is the difference between the Imports (in Local Currency Unit) in Nicaragua and Imports (in Local Currency Unit) in Syrian Arab Republic?
Your response must be concise. -2.95e+11. In the year 2003, what is the difference between the Imports (in Local Currency Unit) in Iraq and Imports (in Local Currency Unit) in Macedonia?
Your response must be concise. 2.26e+13. In the year 2003, what is the difference between the Imports (in Local Currency Unit) of Iraq and Imports (in Local Currency Unit) of Nicaragua?
Ensure brevity in your answer.  2.27e+13. In the year 2003, what is the difference between the Imports (in Local Currency Unit) of Iraq and Imports (in Local Currency Unit) of Syrian Arab Republic?
Your answer should be very brief. 2.24e+13. In the year 2003, what is the difference between the Imports (in Local Currency Unit) in Macedonia and Imports (in Local Currency Unit) in Nicaragua?
Your answer should be very brief. 8.33e+1. In the year 2003, what is the difference between the Imports (in Local Currency Unit) of Macedonia and Imports (in Local Currency Unit) of Syrian Arab Republic?
Keep it short and to the point. -1.90e+11. In the year 2003, what is the difference between the Imports (in Local Currency Unit) of Nicaragua and Imports (in Local Currency Unit) of Syrian Arab Republic?
Your response must be concise. -2.74e+11. In the year 2004, what is the difference between the Imports (in Local Currency Unit) of Iraq and Imports (in Local Currency Unit) of Macedonia?
Make the answer very short. 3.39e+13. In the year 2004, what is the difference between the Imports (in Local Currency Unit) of Iraq and Imports (in Local Currency Unit) of Nicaragua?
Your answer should be very brief. 3.40e+13. In the year 2004, what is the difference between the Imports (in Local Currency Unit) of Iraq and Imports (in Local Currency Unit) of Syrian Arab Republic?
Your answer should be compact. 3.35e+13. In the year 2004, what is the difference between the Imports (in Local Currency Unit) of Macedonia and Imports (in Local Currency Unit) of Nicaragua?
Offer a very short reply. 1.00e+11. In the year 2004, what is the difference between the Imports (in Local Currency Unit) of Macedonia and Imports (in Local Currency Unit) of Syrian Arab Republic?
Your answer should be very brief. -3.64e+11. In the year 2004, what is the difference between the Imports (in Local Currency Unit) of Nicaragua and Imports (in Local Currency Unit) of Syrian Arab Republic?
Your answer should be very brief. -4.64e+11. In the year 2005, what is the difference between the Imports (in Local Currency Unit) of Iraq and Imports (in Local Currency Unit) of Macedonia?
Keep it short and to the point. 4.50e+13. In the year 2005, what is the difference between the Imports (in Local Currency Unit) of Iraq and Imports (in Local Currency Unit) of Nicaragua?
Provide a short and direct response. 4.51e+13. In the year 2005, what is the difference between the Imports (in Local Currency Unit) of Iraq and Imports (in Local Currency Unit) of Syrian Arab Republic?
Provide a succinct answer. 4.45e+13. In the year 2005, what is the difference between the Imports (in Local Currency Unit) of Macedonia and Imports (in Local Currency Unit) of Nicaragua?
Your response must be concise. 1.07e+11. In the year 2005, what is the difference between the Imports (in Local Currency Unit) in Macedonia and Imports (in Local Currency Unit) in Syrian Arab Republic?
Provide a short and direct response. -4.70e+11. In the year 2005, what is the difference between the Imports (in Local Currency Unit) in Nicaragua and Imports (in Local Currency Unit) in Syrian Arab Republic?
Provide a succinct answer. -5.77e+11. In the year 2006, what is the difference between the Imports (in Local Currency Unit) of Iraq and Imports (in Local Currency Unit) of Macedonia?
Your answer should be very brief. 3.67e+13. In the year 2006, what is the difference between the Imports (in Local Currency Unit) of Iraq and Imports (in Local Currency Unit) of Nicaragua?
Your answer should be compact. 3.69e+13. In the year 2006, what is the difference between the Imports (in Local Currency Unit) in Iraq and Imports (in Local Currency Unit) in Syrian Arab Republic?
Keep it short and to the point. 3.63e+13. In the year 2006, what is the difference between the Imports (in Local Currency Unit) in Macedonia and Imports (in Local Currency Unit) in Nicaragua?
Offer a terse response. 1.24e+11. In the year 2006, what is the difference between the Imports (in Local Currency Unit) in Macedonia and Imports (in Local Currency Unit) in Syrian Arab Republic?
Make the answer very short. -4.77e+11. In the year 2006, what is the difference between the Imports (in Local Currency Unit) in Nicaragua and Imports (in Local Currency Unit) in Syrian Arab Republic?
Make the answer very short. -6.01e+11. In the year 2007, what is the difference between the Imports (in Local Currency Unit) in Iraq and Imports (in Local Currency Unit) in Macedonia?
Keep it short and to the point. 3.12e+13. In the year 2007, what is the difference between the Imports (in Local Currency Unit) in Iraq and Imports (in Local Currency Unit) in Nicaragua?
Your response must be concise. 3.13e+13. In the year 2007, what is the difference between the Imports (in Local Currency Unit) in Iraq and Imports (in Local Currency Unit) in Syrian Arab Republic?
Make the answer very short. 3.07e+13. In the year 2007, what is the difference between the Imports (in Local Currency Unit) of Macedonia and Imports (in Local Currency Unit) of Nicaragua?
Provide a succinct answer. 1.57e+11. In the year 2007, what is the difference between the Imports (in Local Currency Unit) in Macedonia and Imports (in Local Currency Unit) in Syrian Arab Republic?
Your answer should be compact. -5.32e+11. In the year 2007, what is the difference between the Imports (in Local Currency Unit) in Nicaragua and Imports (in Local Currency Unit) in Syrian Arab Republic?
Give a very brief answer. -6.90e+11. What is the ratio of the Imports (in Local Currency Unit) in Iraq in 2001 to that in 2002?
Ensure brevity in your answer.  1.26. What is the ratio of the Imports (in Local Currency Unit) of Macedonia in 2001 to that in 2002?
Provide a short and direct response. 0.91. What is the ratio of the Imports (in Local Currency Unit) of Nicaragua in 2001 to that in 2002?
Ensure brevity in your answer.  0.95. What is the ratio of the Imports (in Local Currency Unit) of Syrian Arab Republic in 2001 to that in 2002?
Your answer should be very brief. 0.92. What is the ratio of the Imports (in Local Currency Unit) of Iraq in 2001 to that in 2003?
Give a very brief answer. 1.12. What is the ratio of the Imports (in Local Currency Unit) of Macedonia in 2001 to that in 2003?
Offer a very short reply. 0.91. What is the ratio of the Imports (in Local Currency Unit) of Nicaragua in 2001 to that in 2003?
Your response must be concise. 0.84. What is the ratio of the Imports (in Local Currency Unit) of Syrian Arab Republic in 2001 to that in 2003?
Ensure brevity in your answer.  0.97. What is the ratio of the Imports (in Local Currency Unit) in Iraq in 2001 to that in 2004?
Your answer should be compact. 0.75. What is the ratio of the Imports (in Local Currency Unit) of Macedonia in 2001 to that in 2004?
Ensure brevity in your answer.  0.76. What is the ratio of the Imports (in Local Currency Unit) in Nicaragua in 2001 to that in 2004?
Ensure brevity in your answer.  0.68. What is the ratio of the Imports (in Local Currency Unit) of Syrian Arab Republic in 2001 to that in 2004?
Keep it short and to the point. 0.59. What is the ratio of the Imports (in Local Currency Unit) of Iraq in 2001 to that in 2005?
Offer a very short reply. 0.56. What is the ratio of the Imports (in Local Currency Unit) of Macedonia in 2001 to that in 2005?
Offer a terse response. 0.68. What is the ratio of the Imports (in Local Currency Unit) of Nicaragua in 2001 to that in 2005?
Your answer should be compact. 0.56. What is the ratio of the Imports (in Local Currency Unit) in Syrian Arab Republic in 2001 to that in 2005?
Give a very brief answer. 0.47. What is the ratio of the Imports (in Local Currency Unit) in Iraq in 2001 to that in 2006?
Ensure brevity in your answer.  0.69. What is the ratio of the Imports (in Local Currency Unit) in Macedonia in 2001 to that in 2006?
Your answer should be very brief. 0.58. What is the ratio of the Imports (in Local Currency Unit) of Nicaragua in 2001 to that in 2006?
Give a very brief answer. 0.47. What is the ratio of the Imports (in Local Currency Unit) in Syrian Arab Republic in 2001 to that in 2006?
Your answer should be very brief. 0.45. What is the ratio of the Imports (in Local Currency Unit) of Iraq in 2001 to that in 2007?
Provide a succinct answer. 0.81. What is the ratio of the Imports (in Local Currency Unit) of Macedonia in 2001 to that in 2007?
Your answer should be compact. 0.46. What is the ratio of the Imports (in Local Currency Unit) in Nicaragua in 2001 to that in 2007?
Provide a succinct answer. 0.38. What is the ratio of the Imports (in Local Currency Unit) in Syrian Arab Republic in 2001 to that in 2007?
Offer a terse response. 0.39. What is the ratio of the Imports (in Local Currency Unit) in Iraq in 2002 to that in 2003?
Offer a very short reply. 0.89. What is the ratio of the Imports (in Local Currency Unit) of Nicaragua in 2002 to that in 2003?
Keep it short and to the point. 0.88. What is the ratio of the Imports (in Local Currency Unit) of Syrian Arab Republic in 2002 to that in 2003?
Ensure brevity in your answer.  1.06. What is the ratio of the Imports (in Local Currency Unit) of Iraq in 2002 to that in 2004?
Your answer should be compact. 0.59. What is the ratio of the Imports (in Local Currency Unit) of Macedonia in 2002 to that in 2004?
Your answer should be compact. 0.83. What is the ratio of the Imports (in Local Currency Unit) of Nicaragua in 2002 to that in 2004?
Your response must be concise. 0.72. What is the ratio of the Imports (in Local Currency Unit) in Syrian Arab Republic in 2002 to that in 2004?
Provide a succinct answer. 0.64. What is the ratio of the Imports (in Local Currency Unit) in Iraq in 2002 to that in 2005?
Your response must be concise. 0.45. What is the ratio of the Imports (in Local Currency Unit) in Macedonia in 2002 to that in 2005?
Provide a succinct answer. 0.74. What is the ratio of the Imports (in Local Currency Unit) of Nicaragua in 2002 to that in 2005?
Your response must be concise. 0.58. What is the ratio of the Imports (in Local Currency Unit) of Syrian Arab Republic in 2002 to that in 2005?
Ensure brevity in your answer.  0.52. What is the ratio of the Imports (in Local Currency Unit) of Iraq in 2002 to that in 2006?
Provide a short and direct response. 0.55. What is the ratio of the Imports (in Local Currency Unit) of Macedonia in 2002 to that in 2006?
Provide a short and direct response. 0.64. What is the ratio of the Imports (in Local Currency Unit) of Nicaragua in 2002 to that in 2006?
Provide a short and direct response. 0.49. What is the ratio of the Imports (in Local Currency Unit) in Syrian Arab Republic in 2002 to that in 2006?
Make the answer very short. 0.49. What is the ratio of the Imports (in Local Currency Unit) of Iraq in 2002 to that in 2007?
Offer a terse response. 0.64. What is the ratio of the Imports (in Local Currency Unit) in Macedonia in 2002 to that in 2007?
Offer a very short reply. 0.51. What is the ratio of the Imports (in Local Currency Unit) in Nicaragua in 2002 to that in 2007?
Your answer should be very brief. 0.4. What is the ratio of the Imports (in Local Currency Unit) in Syrian Arab Republic in 2002 to that in 2007?
Offer a terse response. 0.42. What is the ratio of the Imports (in Local Currency Unit) in Iraq in 2003 to that in 2004?
Your answer should be very brief. 0.67. What is the ratio of the Imports (in Local Currency Unit) in Macedonia in 2003 to that in 2004?
Your answer should be very brief. 0.83. What is the ratio of the Imports (in Local Currency Unit) of Nicaragua in 2003 to that in 2004?
Offer a terse response. 0.82. What is the ratio of the Imports (in Local Currency Unit) in Syrian Arab Republic in 2003 to that in 2004?
Your answer should be very brief. 0.61. What is the ratio of the Imports (in Local Currency Unit) in Iraq in 2003 to that in 2005?
Keep it short and to the point. 0.5. What is the ratio of the Imports (in Local Currency Unit) in Macedonia in 2003 to that in 2005?
Ensure brevity in your answer.  0.74. What is the ratio of the Imports (in Local Currency Unit) in Nicaragua in 2003 to that in 2005?
Give a very brief answer. 0.67. What is the ratio of the Imports (in Local Currency Unit) in Syrian Arab Republic in 2003 to that in 2005?
Keep it short and to the point. 0.49. What is the ratio of the Imports (in Local Currency Unit) in Iraq in 2003 to that in 2006?
Make the answer very short. 0.62. What is the ratio of the Imports (in Local Currency Unit) of Macedonia in 2003 to that in 2006?
Your response must be concise. 0.64. What is the ratio of the Imports (in Local Currency Unit) in Nicaragua in 2003 to that in 2006?
Provide a succinct answer. 0.56. What is the ratio of the Imports (in Local Currency Unit) of Syrian Arab Republic in 2003 to that in 2006?
Ensure brevity in your answer.  0.46. What is the ratio of the Imports (in Local Currency Unit) in Iraq in 2003 to that in 2007?
Keep it short and to the point. 0.72. What is the ratio of the Imports (in Local Currency Unit) of Macedonia in 2003 to that in 2007?
Make the answer very short. 0.5. What is the ratio of the Imports (in Local Currency Unit) of Nicaragua in 2003 to that in 2007?
Ensure brevity in your answer.  0.45. What is the ratio of the Imports (in Local Currency Unit) of Syrian Arab Republic in 2003 to that in 2007?
Offer a very short reply. 0.4. What is the ratio of the Imports (in Local Currency Unit) in Iraq in 2004 to that in 2005?
Keep it short and to the point. 0.75. What is the ratio of the Imports (in Local Currency Unit) of Macedonia in 2004 to that in 2005?
Provide a succinct answer. 0.89. What is the ratio of the Imports (in Local Currency Unit) of Nicaragua in 2004 to that in 2005?
Your answer should be compact. 0.81. What is the ratio of the Imports (in Local Currency Unit) in Syrian Arab Republic in 2004 to that in 2005?
Give a very brief answer. 0.8. What is the ratio of the Imports (in Local Currency Unit) in Iraq in 2004 to that in 2006?
Ensure brevity in your answer.  0.92. What is the ratio of the Imports (in Local Currency Unit) of Macedonia in 2004 to that in 2006?
Provide a short and direct response. 0.77. What is the ratio of the Imports (in Local Currency Unit) of Nicaragua in 2004 to that in 2006?
Give a very brief answer. 0.69. What is the ratio of the Imports (in Local Currency Unit) in Syrian Arab Republic in 2004 to that in 2006?
Give a very brief answer. 0.76. What is the ratio of the Imports (in Local Currency Unit) of Iraq in 2004 to that in 2007?
Offer a terse response. 1.08. What is the ratio of the Imports (in Local Currency Unit) in Macedonia in 2004 to that in 2007?
Your answer should be compact. 0.61. What is the ratio of the Imports (in Local Currency Unit) in Nicaragua in 2004 to that in 2007?
Your answer should be compact. 0.55. What is the ratio of the Imports (in Local Currency Unit) of Syrian Arab Republic in 2004 to that in 2007?
Provide a succinct answer. 0.66. What is the ratio of the Imports (in Local Currency Unit) in Iraq in 2005 to that in 2006?
Offer a very short reply. 1.22. What is the ratio of the Imports (in Local Currency Unit) of Macedonia in 2005 to that in 2006?
Offer a terse response. 0.86. What is the ratio of the Imports (in Local Currency Unit) of Nicaragua in 2005 to that in 2006?
Keep it short and to the point. 0.84. What is the ratio of the Imports (in Local Currency Unit) in Syrian Arab Republic in 2005 to that in 2006?
Provide a short and direct response. 0.95. What is the ratio of the Imports (in Local Currency Unit) of Iraq in 2005 to that in 2007?
Give a very brief answer. 1.44. What is the ratio of the Imports (in Local Currency Unit) of Macedonia in 2005 to that in 2007?
Your answer should be very brief. 0.68. What is the ratio of the Imports (in Local Currency Unit) of Nicaragua in 2005 to that in 2007?
Provide a short and direct response. 0.68. What is the ratio of the Imports (in Local Currency Unit) of Syrian Arab Republic in 2005 to that in 2007?
Keep it short and to the point. 0.82. What is the ratio of the Imports (in Local Currency Unit) of Iraq in 2006 to that in 2007?
Provide a succinct answer. 1.17. What is the ratio of the Imports (in Local Currency Unit) of Macedonia in 2006 to that in 2007?
Keep it short and to the point. 0.79. What is the ratio of the Imports (in Local Currency Unit) in Nicaragua in 2006 to that in 2007?
Offer a terse response. 0.8. What is the ratio of the Imports (in Local Currency Unit) in Syrian Arab Republic in 2006 to that in 2007?
Your response must be concise. 0.86. What is the difference between the highest and the second highest Imports (in Local Currency Unit) of Iraq?
Make the answer very short. 8.23e+12. What is the difference between the highest and the second highest Imports (in Local Currency Unit) of Macedonia?
Keep it short and to the point. 4.77e+1. What is the difference between the highest and the second highest Imports (in Local Currency Unit) of Nicaragua?
Provide a succinct answer. 1.44e+1. What is the difference between the highest and the second highest Imports (in Local Currency Unit) of Syrian Arab Republic?
Your answer should be very brief. 1.03e+11. What is the difference between the highest and the lowest Imports (in Local Currency Unit) of Iraq?
Ensure brevity in your answer.  2.50e+13. What is the difference between the highest and the lowest Imports (in Local Currency Unit) of Macedonia?
Your response must be concise. 1.24e+11. What is the difference between the highest and the lowest Imports (in Local Currency Unit) of Nicaragua?
Offer a terse response. 4.58e+1. What is the difference between the highest and the lowest Imports (in Local Currency Unit) in Syrian Arab Republic?
Ensure brevity in your answer.  4.67e+11. 